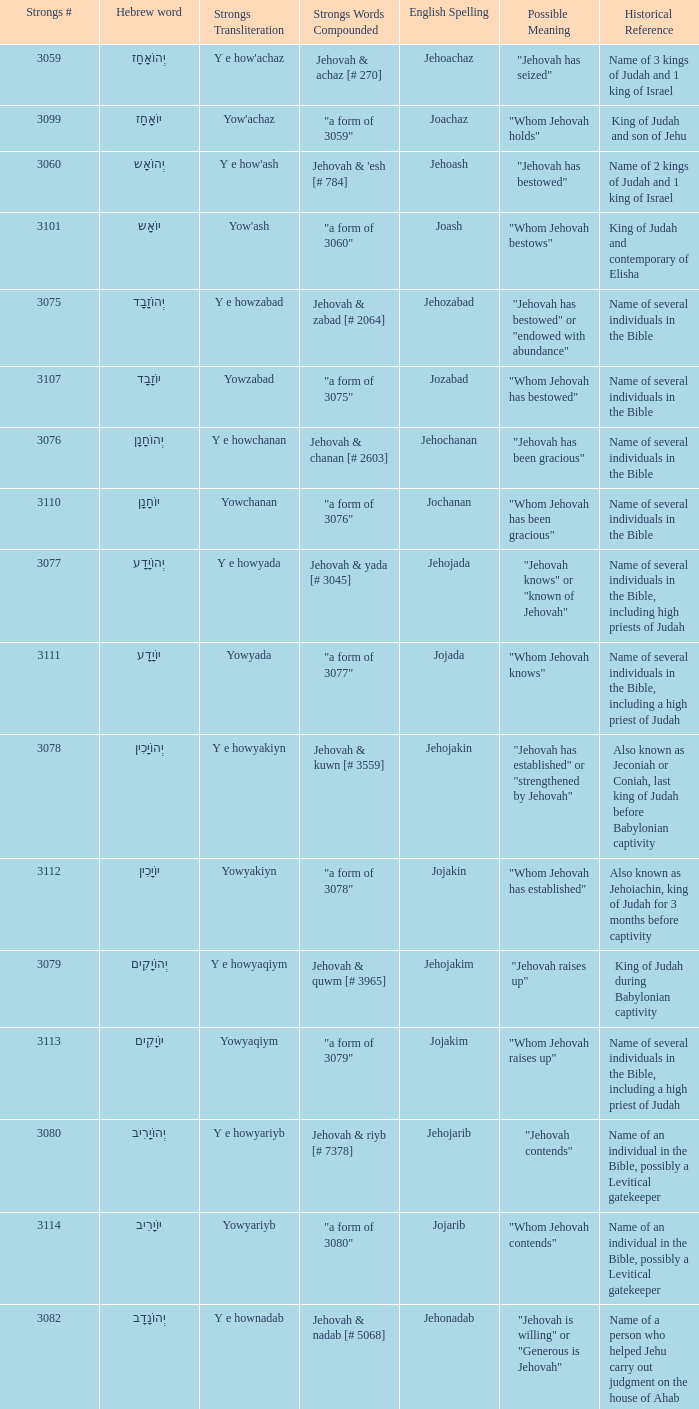What is the strong words compounded when the strongs transliteration is yowyariyb? "a form of 3080". 